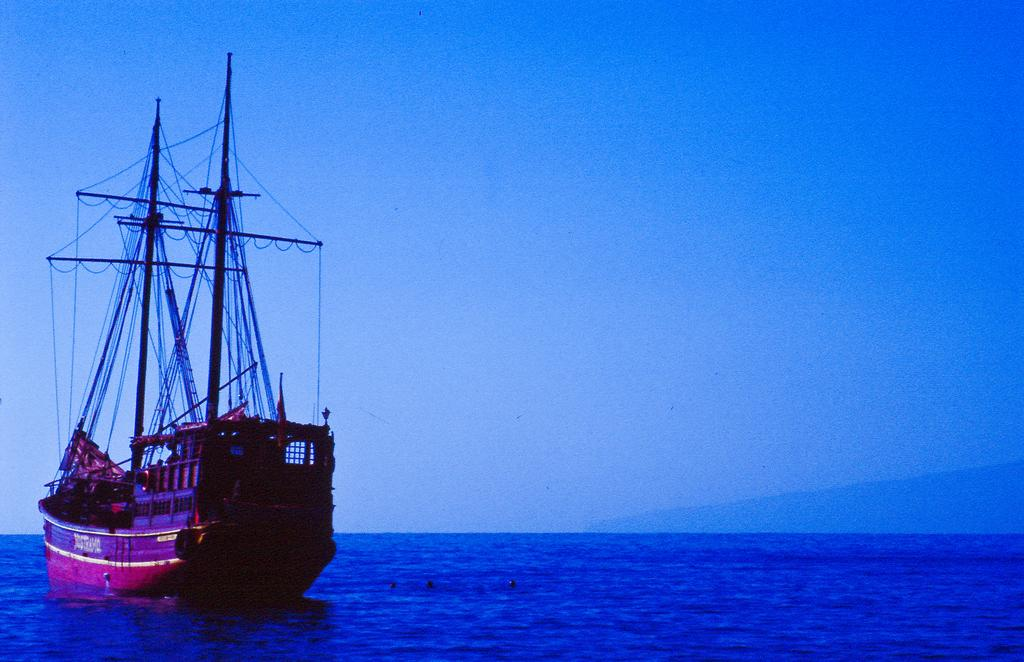What is the main subject of the image? The main subject of the image is a boat. What else can be seen in the image besides the boat? There are wires on poles and water visible in the image. What is visible in the background of the image? The sky is visible in the background of the image. What type of lunch is being served at the party in the image? There is no lunch or party present in the image; it features a boat, wires on poles, water, and the sky. How much sugar is visible in the image? There is no sugar visible in the image. 